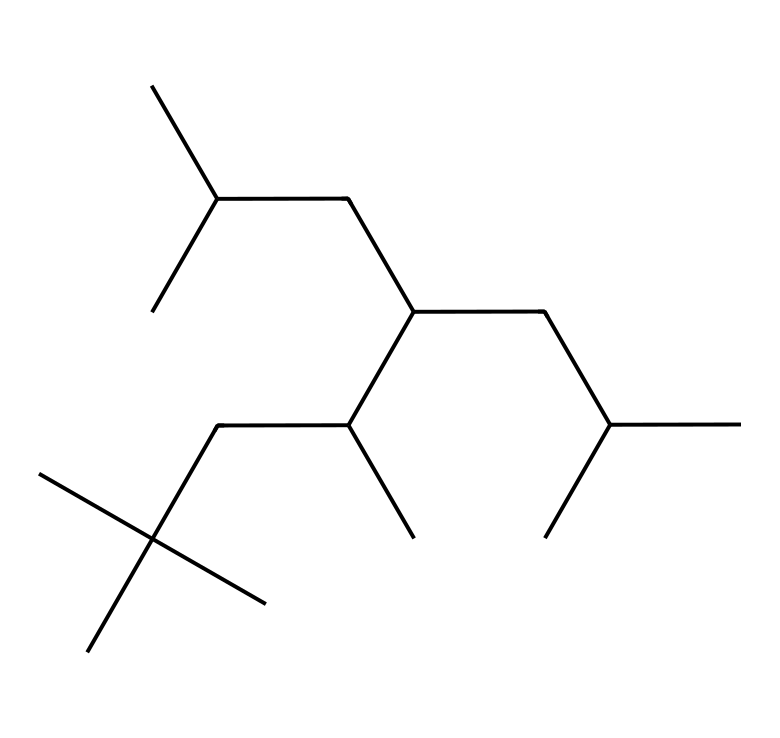What is the molecular formula of this compound? To determine the molecular formula, we need to count the number of carbon and hydrogen atoms in the chemical structure represented by the SMILES. The structure indicates there are 15 carbon atoms and 30 hydrogen atoms, leading us to the formula C15H30.
Answer: C15H30 How many branches are present in this polyalphaolefin? By analyzing the structure, we can see several branching points where carbon chains extend from the main chain. Counting these, we find that there are 5 distinct branches in this particular structure.
Answer: 5 What type of chemical is represented by this structure? This structure represents a polyalphaolefin, which is a type of synthetic hydrocarbon used in lubricants. This classification is determined by the polymerized structure derived from alpha-olefins.
Answer: polyalphaolefin What is the significance of the straight-chain structure in lubricants? The straight-chain structure is important because it contributes to the lubricating properties and viscosity of the lubricant, allowing for effective performance in reducing friction and wear in mechanical systems.
Answer: viscosity Is this compound likely to be biodegradable? The structure of polyalphaolefins indicates they are typically not biodegradable, leading to a conclusion that compounds of this nature may persist in the environment.
Answer: no What is the primary use of compounds with this structure? Compounds with this structure are primarily used as lubricants in various applications, including automotive and industrial settings, due to their favorable properties.
Answer: lubricants 